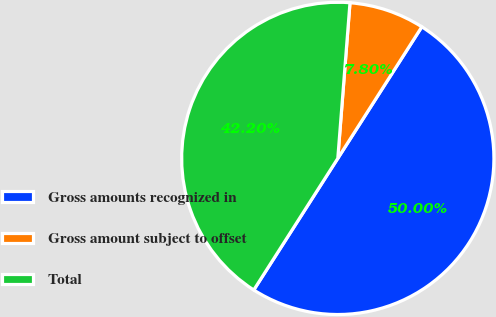Convert chart. <chart><loc_0><loc_0><loc_500><loc_500><pie_chart><fcel>Gross amounts recognized in<fcel>Gross amount subject to offset<fcel>Total<nl><fcel>50.0%<fcel>7.8%<fcel>42.2%<nl></chart> 